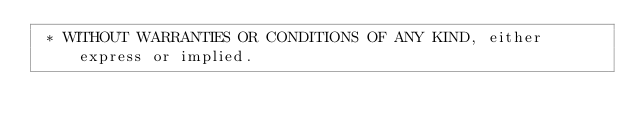Convert code to text. <code><loc_0><loc_0><loc_500><loc_500><_Java_> * WITHOUT WARRANTIES OR CONDITIONS OF ANY KIND, either express or implied.</code> 